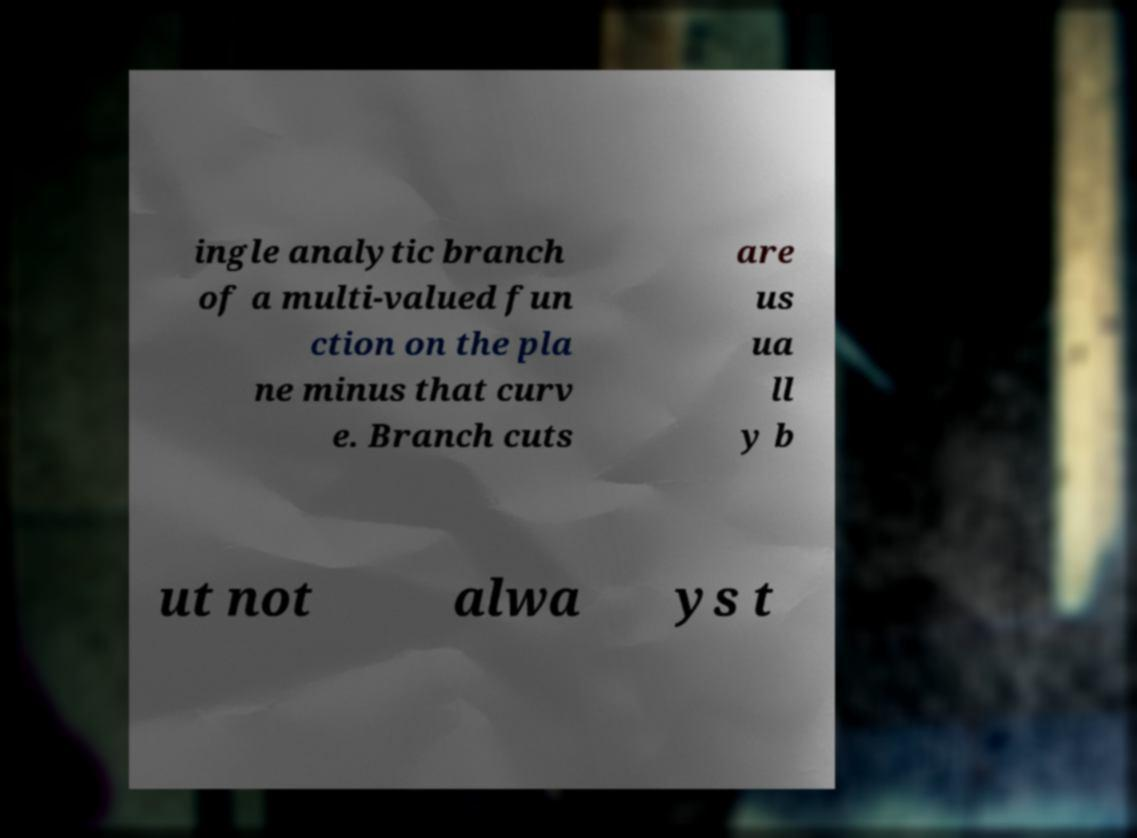Could you extract and type out the text from this image? ingle analytic branch of a multi-valued fun ction on the pla ne minus that curv e. Branch cuts are us ua ll y b ut not alwa ys t 